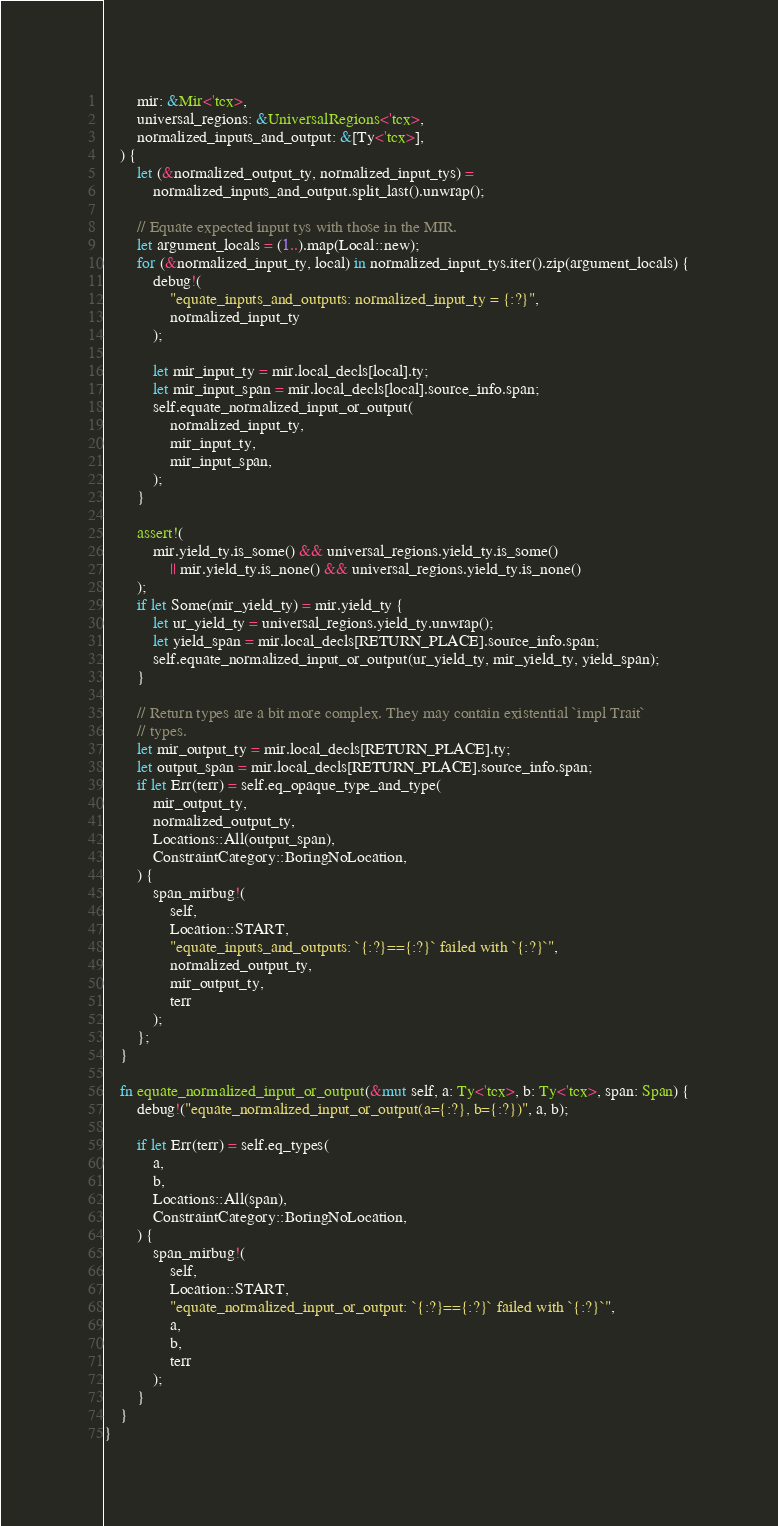Convert code to text. <code><loc_0><loc_0><loc_500><loc_500><_Rust_>        mir: &Mir<'tcx>,
        universal_regions: &UniversalRegions<'tcx>,
        normalized_inputs_and_output: &[Ty<'tcx>],
    ) {
        let (&normalized_output_ty, normalized_input_tys) =
            normalized_inputs_and_output.split_last().unwrap();

        // Equate expected input tys with those in the MIR.
        let argument_locals = (1..).map(Local::new);
        for (&normalized_input_ty, local) in normalized_input_tys.iter().zip(argument_locals) {
            debug!(
                "equate_inputs_and_outputs: normalized_input_ty = {:?}",
                normalized_input_ty
            );

            let mir_input_ty = mir.local_decls[local].ty;
            let mir_input_span = mir.local_decls[local].source_info.span;
            self.equate_normalized_input_or_output(
                normalized_input_ty,
                mir_input_ty,
                mir_input_span,
            );
        }

        assert!(
            mir.yield_ty.is_some() && universal_regions.yield_ty.is_some()
                || mir.yield_ty.is_none() && universal_regions.yield_ty.is_none()
        );
        if let Some(mir_yield_ty) = mir.yield_ty {
            let ur_yield_ty = universal_regions.yield_ty.unwrap();
            let yield_span = mir.local_decls[RETURN_PLACE].source_info.span;
            self.equate_normalized_input_or_output(ur_yield_ty, mir_yield_ty, yield_span);
        }

        // Return types are a bit more complex. They may contain existential `impl Trait`
        // types.
        let mir_output_ty = mir.local_decls[RETURN_PLACE].ty;
        let output_span = mir.local_decls[RETURN_PLACE].source_info.span;
        if let Err(terr) = self.eq_opaque_type_and_type(
            mir_output_ty,
            normalized_output_ty,
            Locations::All(output_span),
            ConstraintCategory::BoringNoLocation,
        ) {
            span_mirbug!(
                self,
                Location::START,
                "equate_inputs_and_outputs: `{:?}=={:?}` failed with `{:?}`",
                normalized_output_ty,
                mir_output_ty,
                terr
            );
        };
    }

    fn equate_normalized_input_or_output(&mut self, a: Ty<'tcx>, b: Ty<'tcx>, span: Span) {
        debug!("equate_normalized_input_or_output(a={:?}, b={:?})", a, b);

        if let Err(terr) = self.eq_types(
            a,
            b,
            Locations::All(span),
            ConstraintCategory::BoringNoLocation,
        ) {
            span_mirbug!(
                self,
                Location::START,
                "equate_normalized_input_or_output: `{:?}=={:?}` failed with `{:?}`",
                a,
                b,
                terr
            );
        }
    }
}
</code> 